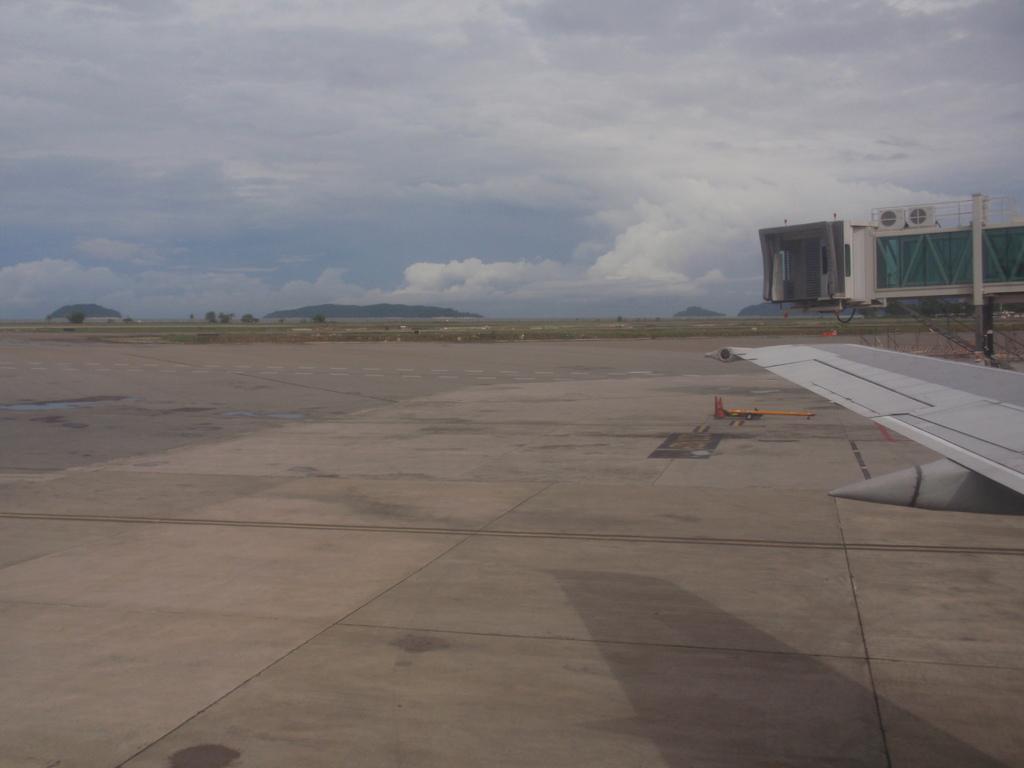How would you summarize this image in a sentence or two? In this image we can see open area. Right side of the image aeroplane wing and building is there. At the top sky is covered with clouds. 